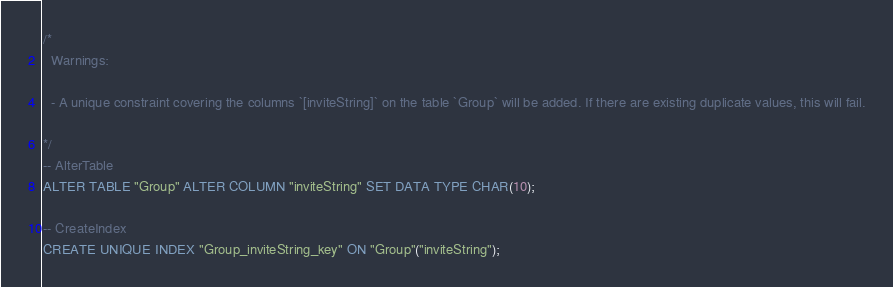<code> <loc_0><loc_0><loc_500><loc_500><_SQL_>/*
  Warnings:

  - A unique constraint covering the columns `[inviteString]` on the table `Group` will be added. If there are existing duplicate values, this will fail.

*/
-- AlterTable
ALTER TABLE "Group" ALTER COLUMN "inviteString" SET DATA TYPE CHAR(10);

-- CreateIndex
CREATE UNIQUE INDEX "Group_inviteString_key" ON "Group"("inviteString");
</code> 